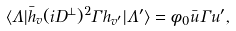<formula> <loc_0><loc_0><loc_500><loc_500>\langle \Lambda | \bar { h } _ { v } ( i D ^ { \perp } ) ^ { 2 } \Gamma h _ { v ^ { \prime } } | \Lambda ^ { \prime } \rangle = \phi _ { 0 } \bar { u } \Gamma u ^ { \prime } ,</formula> 